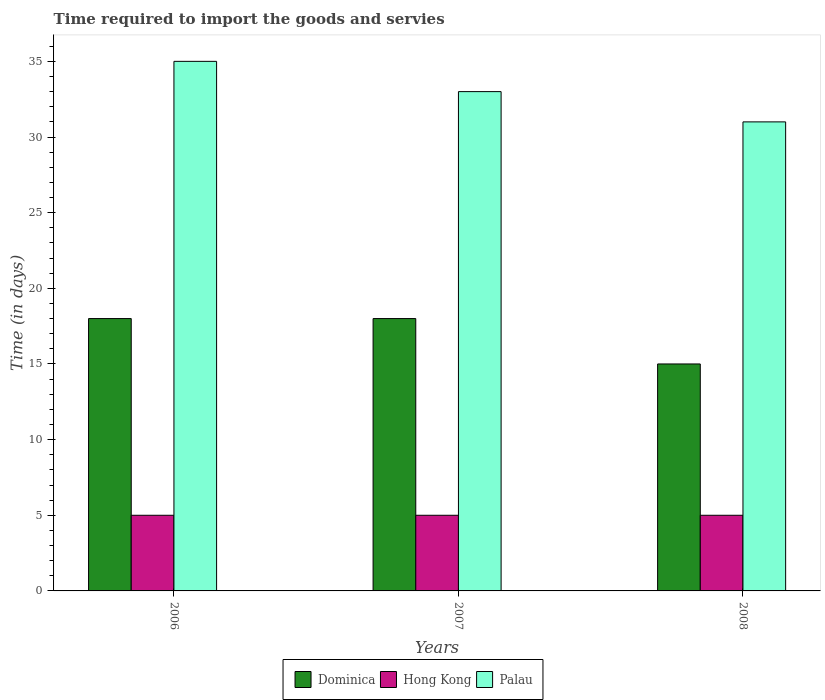How many different coloured bars are there?
Offer a terse response. 3. How many groups of bars are there?
Your response must be concise. 3. Are the number of bars per tick equal to the number of legend labels?
Your response must be concise. Yes. How many bars are there on the 2nd tick from the right?
Give a very brief answer. 3. What is the number of days required to import the goods and services in Dominica in 2008?
Your response must be concise. 15. Across all years, what is the maximum number of days required to import the goods and services in Dominica?
Provide a short and direct response. 18. Across all years, what is the minimum number of days required to import the goods and services in Palau?
Offer a very short reply. 31. What is the total number of days required to import the goods and services in Palau in the graph?
Keep it short and to the point. 99. What is the difference between the number of days required to import the goods and services in Hong Kong in 2006 and that in 2007?
Make the answer very short. 0. What is the difference between the number of days required to import the goods and services in Palau in 2008 and the number of days required to import the goods and services in Hong Kong in 2007?
Offer a very short reply. 26. In the year 2006, what is the difference between the number of days required to import the goods and services in Hong Kong and number of days required to import the goods and services in Palau?
Your answer should be very brief. -30. Is the number of days required to import the goods and services in Dominica in 2006 less than that in 2007?
Your response must be concise. No. Is the difference between the number of days required to import the goods and services in Hong Kong in 2007 and 2008 greater than the difference between the number of days required to import the goods and services in Palau in 2007 and 2008?
Provide a succinct answer. No. What is the difference between the highest and the lowest number of days required to import the goods and services in Palau?
Your answer should be compact. 4. What does the 2nd bar from the left in 2006 represents?
Ensure brevity in your answer.  Hong Kong. What does the 3rd bar from the right in 2007 represents?
Provide a short and direct response. Dominica. How many bars are there?
Give a very brief answer. 9. What is the difference between two consecutive major ticks on the Y-axis?
Provide a short and direct response. 5. Are the values on the major ticks of Y-axis written in scientific E-notation?
Your answer should be very brief. No. Does the graph contain any zero values?
Ensure brevity in your answer.  No. How are the legend labels stacked?
Offer a terse response. Horizontal. What is the title of the graph?
Make the answer very short. Time required to import the goods and servies. What is the label or title of the Y-axis?
Your answer should be compact. Time (in days). What is the Time (in days) of Dominica in 2006?
Your answer should be compact. 18. What is the Time (in days) of Palau in 2006?
Give a very brief answer. 35. What is the Time (in days) in Hong Kong in 2007?
Your answer should be very brief. 5. What is the Time (in days) of Palau in 2007?
Ensure brevity in your answer.  33. What is the Time (in days) in Hong Kong in 2008?
Ensure brevity in your answer.  5. What is the Time (in days) of Palau in 2008?
Give a very brief answer. 31. Across all years, what is the maximum Time (in days) of Dominica?
Give a very brief answer. 18. Across all years, what is the maximum Time (in days) of Hong Kong?
Your response must be concise. 5. Across all years, what is the maximum Time (in days) in Palau?
Give a very brief answer. 35. Across all years, what is the minimum Time (in days) in Dominica?
Provide a short and direct response. 15. Across all years, what is the minimum Time (in days) in Hong Kong?
Ensure brevity in your answer.  5. Across all years, what is the minimum Time (in days) of Palau?
Your response must be concise. 31. What is the total Time (in days) in Palau in the graph?
Offer a very short reply. 99. What is the difference between the Time (in days) of Hong Kong in 2006 and that in 2007?
Give a very brief answer. 0. What is the difference between the Time (in days) of Dominica in 2006 and that in 2008?
Offer a terse response. 3. What is the difference between the Time (in days) of Hong Kong in 2006 and that in 2008?
Your response must be concise. 0. What is the difference between the Time (in days) in Palau in 2006 and that in 2008?
Give a very brief answer. 4. What is the difference between the Time (in days) of Dominica in 2006 and the Time (in days) of Palau in 2007?
Make the answer very short. -15. What is the difference between the Time (in days) in Hong Kong in 2006 and the Time (in days) in Palau in 2007?
Offer a terse response. -28. What is the difference between the Time (in days) in Hong Kong in 2006 and the Time (in days) in Palau in 2008?
Ensure brevity in your answer.  -26. What is the difference between the Time (in days) in Dominica in 2007 and the Time (in days) in Hong Kong in 2008?
Ensure brevity in your answer.  13. What is the average Time (in days) of Dominica per year?
Provide a short and direct response. 17. What is the average Time (in days) of Hong Kong per year?
Ensure brevity in your answer.  5. In the year 2006, what is the difference between the Time (in days) in Hong Kong and Time (in days) in Palau?
Your answer should be very brief. -30. In the year 2007, what is the difference between the Time (in days) of Dominica and Time (in days) of Hong Kong?
Your answer should be compact. 13. In the year 2007, what is the difference between the Time (in days) in Dominica and Time (in days) in Palau?
Provide a succinct answer. -15. In the year 2007, what is the difference between the Time (in days) in Hong Kong and Time (in days) in Palau?
Ensure brevity in your answer.  -28. In the year 2008, what is the difference between the Time (in days) in Dominica and Time (in days) in Hong Kong?
Keep it short and to the point. 10. In the year 2008, what is the difference between the Time (in days) of Hong Kong and Time (in days) of Palau?
Offer a terse response. -26. What is the ratio of the Time (in days) of Dominica in 2006 to that in 2007?
Give a very brief answer. 1. What is the ratio of the Time (in days) in Hong Kong in 2006 to that in 2007?
Keep it short and to the point. 1. What is the ratio of the Time (in days) of Palau in 2006 to that in 2007?
Make the answer very short. 1.06. What is the ratio of the Time (in days) of Hong Kong in 2006 to that in 2008?
Keep it short and to the point. 1. What is the ratio of the Time (in days) of Palau in 2006 to that in 2008?
Keep it short and to the point. 1.13. What is the ratio of the Time (in days) in Palau in 2007 to that in 2008?
Provide a succinct answer. 1.06. What is the difference between the highest and the second highest Time (in days) of Dominica?
Ensure brevity in your answer.  0. What is the difference between the highest and the second highest Time (in days) of Hong Kong?
Your answer should be very brief. 0. What is the difference between the highest and the second highest Time (in days) in Palau?
Your answer should be compact. 2. What is the difference between the highest and the lowest Time (in days) of Hong Kong?
Provide a succinct answer. 0. What is the difference between the highest and the lowest Time (in days) in Palau?
Ensure brevity in your answer.  4. 